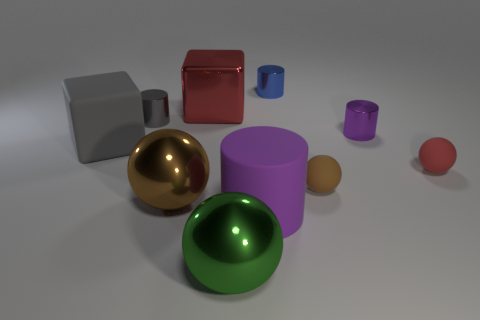Does the shiny ball in front of the brown metal sphere have the same size as the brown matte thing? No, the shiny golden ball in front of the brown metal sphere appears noticeably larger than the small brown matte object to the right. 